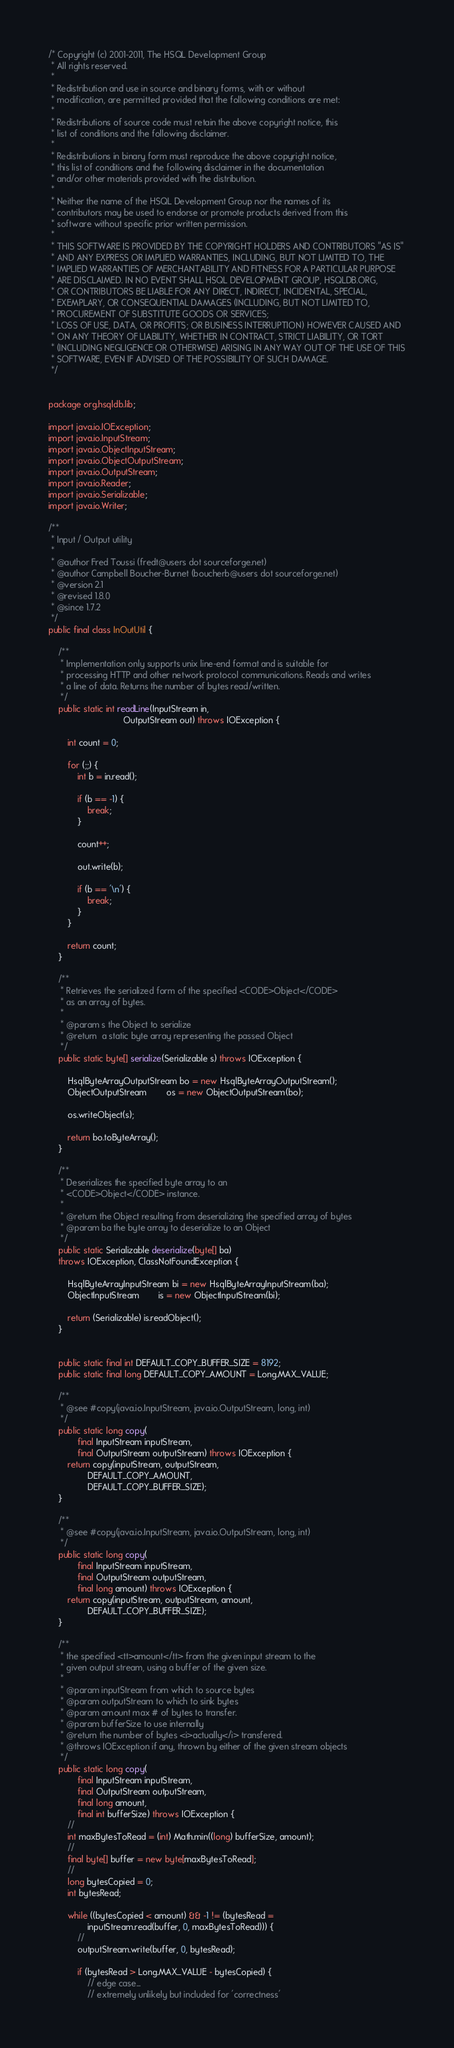<code> <loc_0><loc_0><loc_500><loc_500><_Java_>/* Copyright (c) 2001-2011, The HSQL Development Group
 * All rights reserved.
 *
 * Redistribution and use in source and binary forms, with or without
 * modification, are permitted provided that the following conditions are met:
 *
 * Redistributions of source code must retain the above copyright notice, this
 * list of conditions and the following disclaimer.
 *
 * Redistributions in binary form must reproduce the above copyright notice,
 * this list of conditions and the following disclaimer in the documentation
 * and/or other materials provided with the distribution.
 *
 * Neither the name of the HSQL Development Group nor the names of its
 * contributors may be used to endorse or promote products derived from this
 * software without specific prior written permission.
 *
 * THIS SOFTWARE IS PROVIDED BY THE COPYRIGHT HOLDERS AND CONTRIBUTORS "AS IS"
 * AND ANY EXPRESS OR IMPLIED WARRANTIES, INCLUDING, BUT NOT LIMITED TO, THE
 * IMPLIED WARRANTIES OF MERCHANTABILITY AND FITNESS FOR A PARTICULAR PURPOSE
 * ARE DISCLAIMED. IN NO EVENT SHALL HSQL DEVELOPMENT GROUP, HSQLDB.ORG,
 * OR CONTRIBUTORS BE LIABLE FOR ANY DIRECT, INDIRECT, INCIDENTAL, SPECIAL,
 * EXEMPLARY, OR CONSEQUENTIAL DAMAGES (INCLUDING, BUT NOT LIMITED TO,
 * PROCUREMENT OF SUBSTITUTE GOODS OR SERVICES;
 * LOSS OF USE, DATA, OR PROFITS; OR BUSINESS INTERRUPTION) HOWEVER CAUSED AND
 * ON ANY THEORY OF LIABILITY, WHETHER IN CONTRACT, STRICT LIABILITY, OR TORT
 * (INCLUDING NEGLIGENCE OR OTHERWISE) ARISING IN ANY WAY OUT OF THE USE OF THIS
 * SOFTWARE, EVEN IF ADVISED OF THE POSSIBILITY OF SUCH DAMAGE.
 */


package org.hsqldb.lib;

import java.io.IOException;
import java.io.InputStream;
import java.io.ObjectInputStream;
import java.io.ObjectOutputStream;
import java.io.OutputStream;
import java.io.Reader;
import java.io.Serializable;
import java.io.Writer;

/**
 * Input / Output utility
 *
 * @author Fred Toussi (fredt@users dot sourceforge.net)
 * @author Campbell Boucher-Burnet (boucherb@users dot sourceforge.net)
 * @version 2.1
 * @revised 1.8.0
 * @since 1.7.2
 */
public final class InOutUtil {

    /**
     * Implementation only supports unix line-end format and is suitable for
     * processing HTTP and other network protocol communications. Reads and writes
     * a line of data. Returns the number of bytes read/written.
     */
    public static int readLine(InputStream in,
                               OutputStream out) throws IOException {

        int count = 0;

        for (;;) {
            int b = in.read();

            if (b == -1) {
                break;
            }

            count++;

            out.write(b);

            if (b == '\n') {
                break;
            }
        }

        return count;
    }

    /**
     * Retrieves the serialized form of the specified <CODE>Object</CODE>
     * as an array of bytes.
     *
     * @param s the Object to serialize
     * @return  a static byte array representing the passed Object
     */
    public static byte[] serialize(Serializable s) throws IOException {

        HsqlByteArrayOutputStream bo = new HsqlByteArrayOutputStream();
        ObjectOutputStream        os = new ObjectOutputStream(bo);

        os.writeObject(s);

        return bo.toByteArray();
    }

    /**
     * Deserializes the specified byte array to an
     * <CODE>Object</CODE> instance.
     *
     * @return the Object resulting from deserializing the specified array of bytes
     * @param ba the byte array to deserialize to an Object
     */
    public static Serializable deserialize(byte[] ba)
    throws IOException, ClassNotFoundException {

        HsqlByteArrayInputStream bi = new HsqlByteArrayInputStream(ba);
        ObjectInputStream        is = new ObjectInputStream(bi);

        return (Serializable) is.readObject();
    }


    public static final int DEFAULT_COPY_BUFFER_SIZE = 8192;
    public static final long DEFAULT_COPY_AMOUNT = Long.MAX_VALUE;

    /**
     * @see #copy(java.io.InputStream, java.io.OutputStream, long, int)
     */
    public static long copy(
            final InputStream inputStream,
            final OutputStream outputStream) throws IOException {
        return copy(inputStream, outputStream,
                DEFAULT_COPY_AMOUNT,
                DEFAULT_COPY_BUFFER_SIZE);
    }

    /**
     * @see #copy(java.io.InputStream, java.io.OutputStream, long, int)
     */
    public static long copy(
            final InputStream inputStream,
            final OutputStream outputStream,
            final long amount) throws IOException {
        return copy(inputStream, outputStream, amount,
                DEFAULT_COPY_BUFFER_SIZE);
    }
    
    /**
     * the specified <tt>amount</tt> from the given input stream to the
     * given output stream, using a buffer of the given size.
     *
     * @param inputStream from which to source bytes
     * @param outputStream to which to sink bytes
     * @param amount max # of bytes to transfer.
     * @param bufferSize to use internally
     * @return the number of bytes <i>actually</i> transfered.
     * @throws IOException if any, thrown by either of the given stream objects
     */
    public static long copy(
            final InputStream inputStream,
            final OutputStream outputStream,
            final long amount,
            final int bufferSize) throws IOException {
        //
        int maxBytesToRead = (int) Math.min((long) bufferSize, amount);
        //
        final byte[] buffer = new byte[maxBytesToRead];
        //
        long bytesCopied = 0;
        int bytesRead;        

        while ((bytesCopied < amount) && -1 != (bytesRead =
                inputStream.read(buffer, 0, maxBytesToRead))) {
            //
            outputStream.write(buffer, 0, bytesRead);

            if (bytesRead > Long.MAX_VALUE - bytesCopied) {
                // edge case...
                // extremely unlikely but included for 'correctness'</code> 